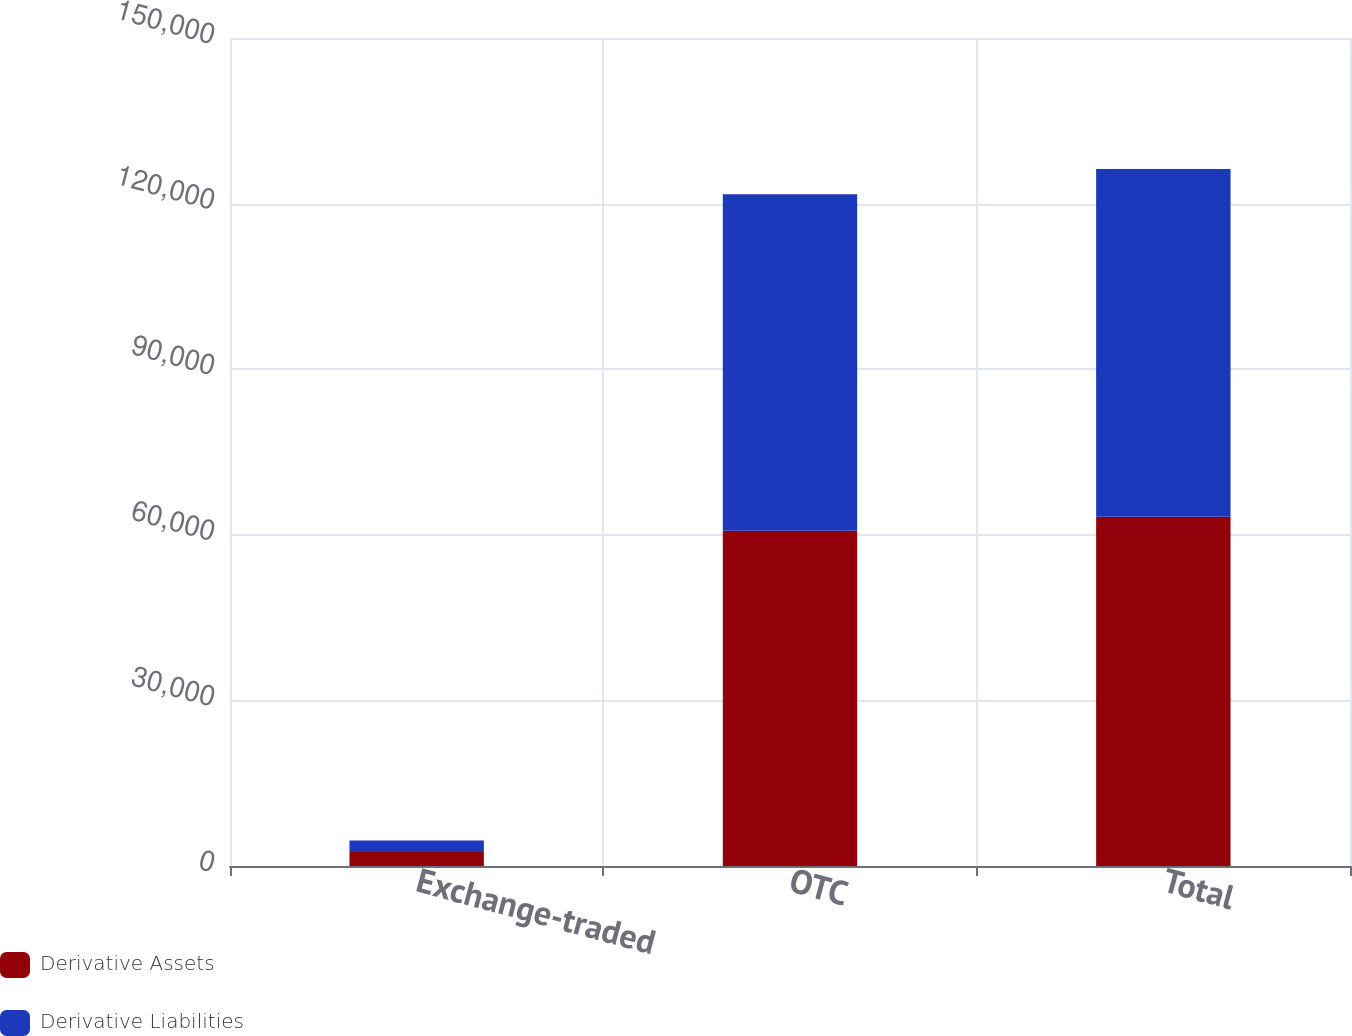<chart> <loc_0><loc_0><loc_500><loc_500><stacked_bar_chart><ecel><fcel>Exchange-traded<fcel>OTC<fcel>Total<nl><fcel>Derivative Assets<fcel>2533<fcel>60737<fcel>63270<nl><fcel>Derivative Liabilities<fcel>2070<fcel>60946<fcel>63016<nl></chart> 